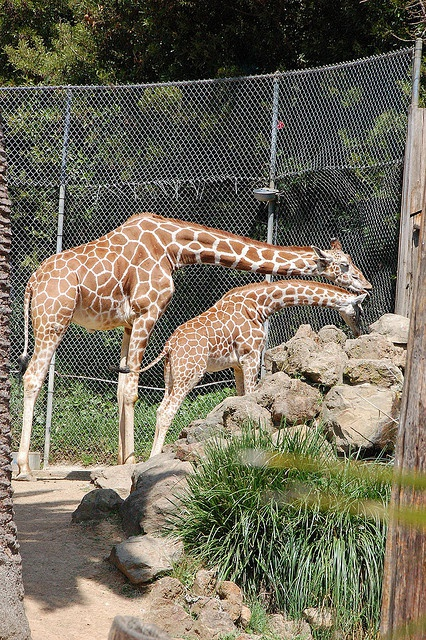Describe the objects in this image and their specific colors. I can see giraffe in darkgreen, white, tan, and black tones and giraffe in darkgreen, white, tan, and gray tones in this image. 